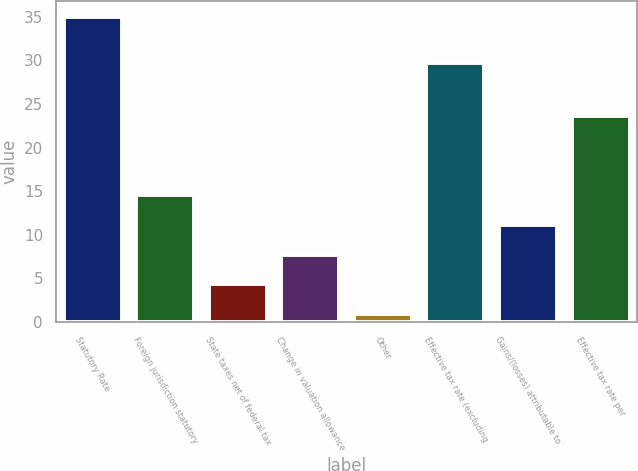Convert chart. <chart><loc_0><loc_0><loc_500><loc_500><bar_chart><fcel>Statutory Rate<fcel>Foreign jurisdiction statutory<fcel>State taxes net of federal tax<fcel>Change in valuation allowance<fcel>Other<fcel>Effective tax rate (excluding<fcel>Gains/(losses) attributable to<fcel>Effective tax rate per<nl><fcel>35<fcel>14.54<fcel>4.31<fcel>7.72<fcel>0.9<fcel>29.7<fcel>11.13<fcel>23.6<nl></chart> 